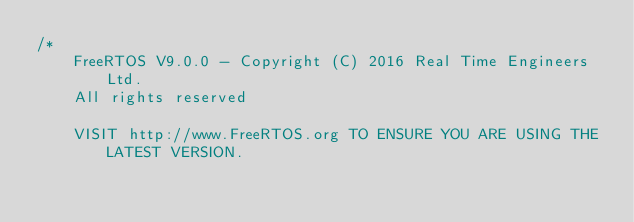Convert code to text. <code><loc_0><loc_0><loc_500><loc_500><_C_>/*
    FreeRTOS V9.0.0 - Copyright (C) 2016 Real Time Engineers Ltd.
    All rights reserved

    VISIT http://www.FreeRTOS.org TO ENSURE YOU ARE USING THE LATEST VERSION.
</code> 